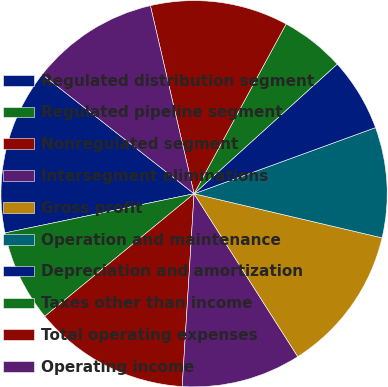Convert chart. <chart><loc_0><loc_0><loc_500><loc_500><pie_chart><fcel>Regulated distribution segment<fcel>Regulated pipeline segment<fcel>Nonregulated segment<fcel>Intersegment eliminations<fcel>Gross profit<fcel>Operation and maintenance<fcel>Depreciation and amortization<fcel>Taxes other than income<fcel>Total operating expenses<fcel>Operating income<nl><fcel>13.85%<fcel>7.69%<fcel>13.08%<fcel>10.0%<fcel>12.31%<fcel>9.23%<fcel>6.15%<fcel>5.38%<fcel>11.54%<fcel>10.77%<nl></chart> 